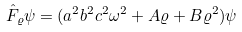Convert formula to latex. <formula><loc_0><loc_0><loc_500><loc_500>\hat { F } _ { \varrho } \psi = ( a ^ { 2 } b ^ { 2 } c ^ { 2 } \omega ^ { 2 } + A \varrho + B \varrho ^ { 2 } ) \psi</formula> 